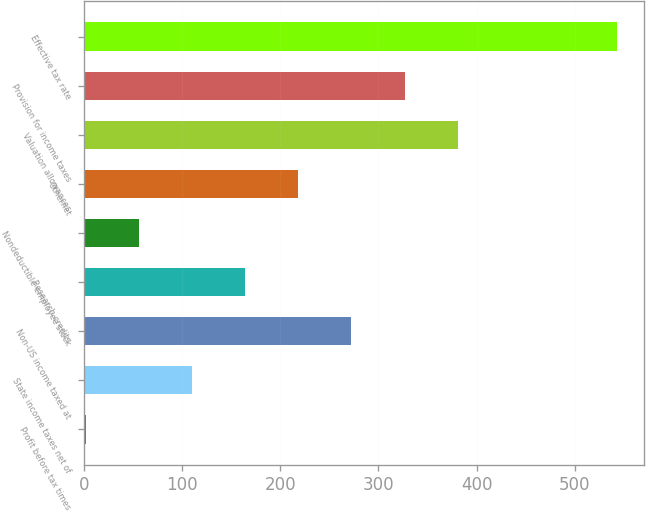Convert chart to OTSL. <chart><loc_0><loc_0><loc_500><loc_500><bar_chart><fcel>Profit before tax times<fcel>State income taxes net of<fcel>Non-US income taxed at<fcel>Research credits<fcel>Nondeductible employee stock<fcel>Othernet<fcel>Valuation allowances<fcel>Provision for income taxes<fcel>Effective tax rate<nl><fcel>2<fcel>110.2<fcel>272.5<fcel>164.3<fcel>56.1<fcel>218.4<fcel>380.7<fcel>326.6<fcel>543<nl></chart> 